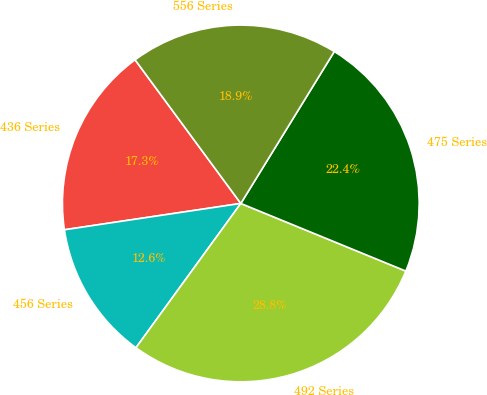Convert chart. <chart><loc_0><loc_0><loc_500><loc_500><pie_chart><fcel>436 Series<fcel>456 Series<fcel>492 Series<fcel>475 Series<fcel>556 Series<nl><fcel>17.26%<fcel>12.64%<fcel>28.81%<fcel>22.41%<fcel>18.88%<nl></chart> 